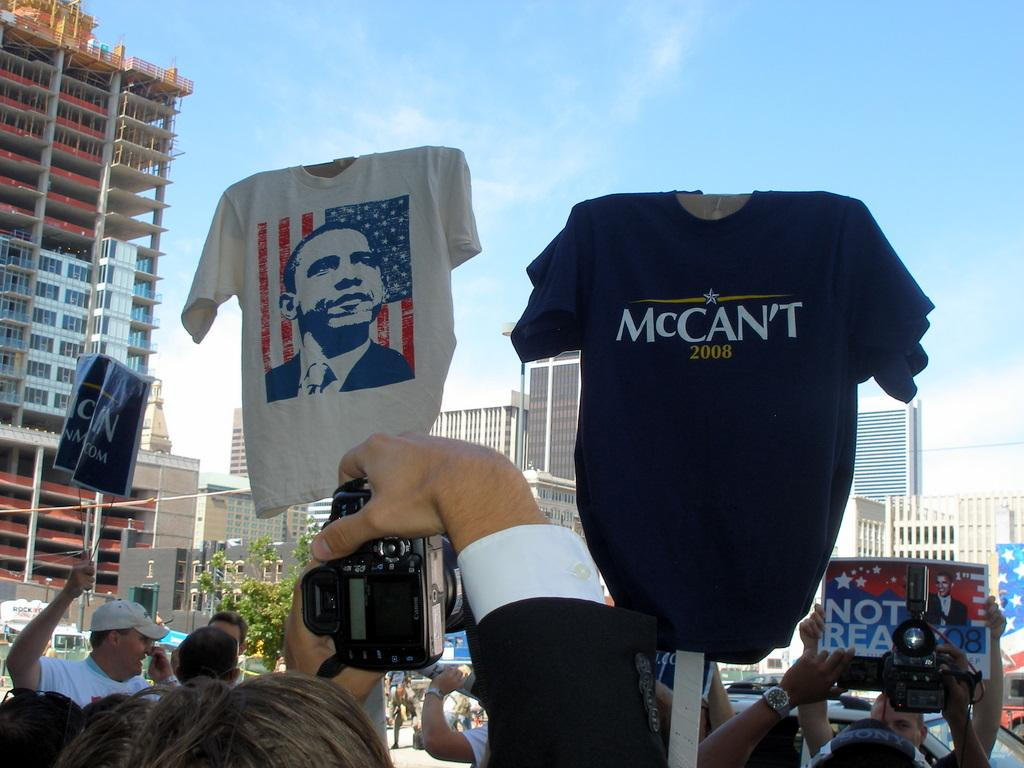<image>
Write a terse but informative summary of the picture. A rally with two shirts being held up, one with a picture of Obama, the other with McCan't 2008 on it. 